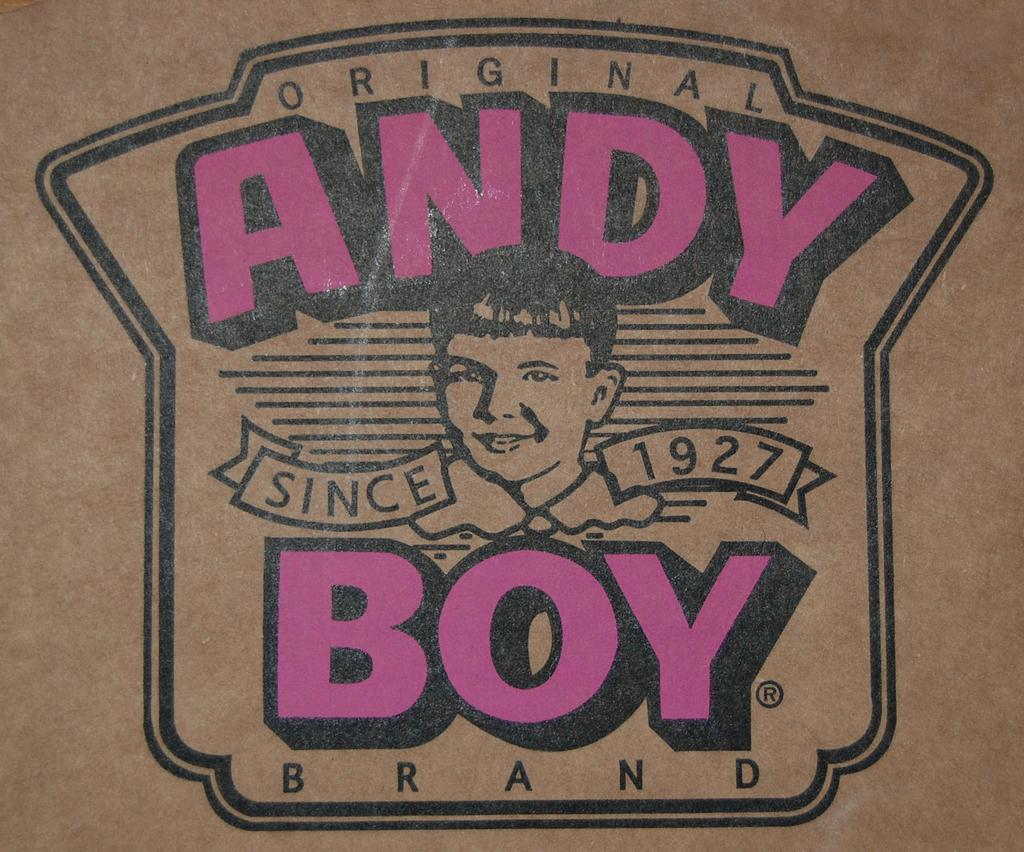What is on the brown surface in the image? There is a logo on a brown surface in the image. What colors are used for the text in the image? The edited text in the image is in purple and black colors. Can you describe the person's face in the image? A person's face is visible in the image. What type of shoe is the person wearing on the stage in the image? There is no shoe or stage present in the image; it only features a logo on a brown surface and edited text in purple and black colors, along with a person's face. 